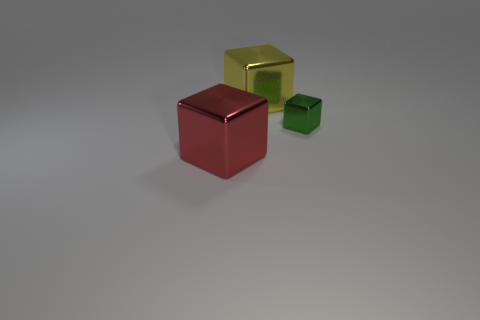Add 2 large red metal things. How many objects exist? 5 Add 1 large cyan objects. How many large cyan objects exist? 1 Subtract 1 red cubes. How many objects are left? 2 Subtract all big yellow blocks. Subtract all tiny brown blocks. How many objects are left? 2 Add 1 yellow shiny blocks. How many yellow shiny blocks are left? 2 